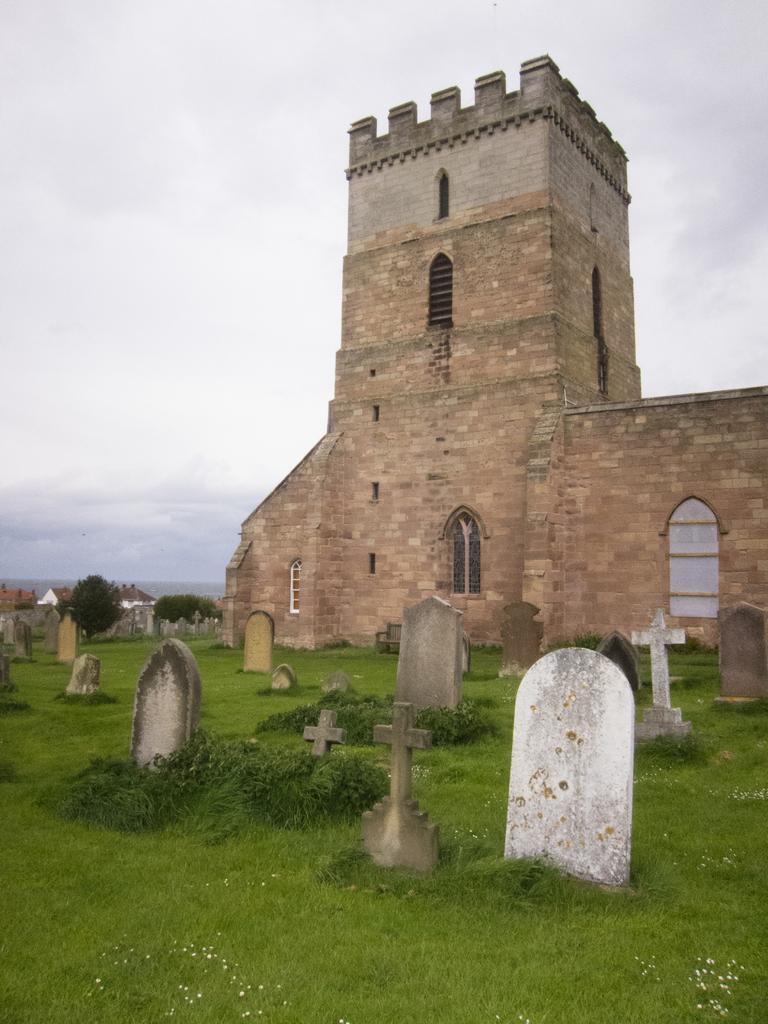In one or two sentences, can you explain what this image depicts? In this image we can see graves. In the background of the image there is a building with windows. At the bottom of the image there is grass. At the top of the image there is sky and clouds. 